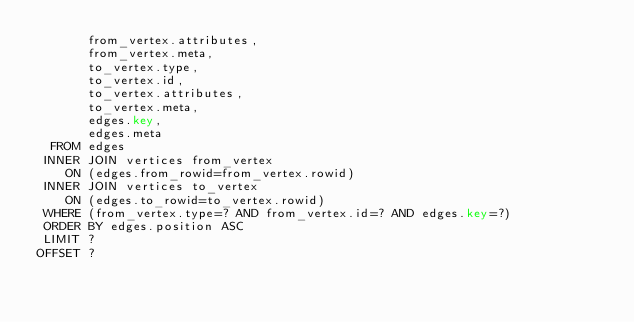Convert code to text. <code><loc_0><loc_0><loc_500><loc_500><_SQL_>       from_vertex.attributes,
       from_vertex.meta,
       to_vertex.type,
       to_vertex.id,
       to_vertex.attributes,
       to_vertex.meta,
       edges.key,
       edges.meta
  FROM edges
 INNER JOIN vertices from_vertex
    ON (edges.from_rowid=from_vertex.rowid)
 INNER JOIN vertices to_vertex
    ON (edges.to_rowid=to_vertex.rowid)
 WHERE (from_vertex.type=? AND from_vertex.id=? AND edges.key=?)
 ORDER BY edges.position ASC
 LIMIT ?
OFFSET ?
</code> 